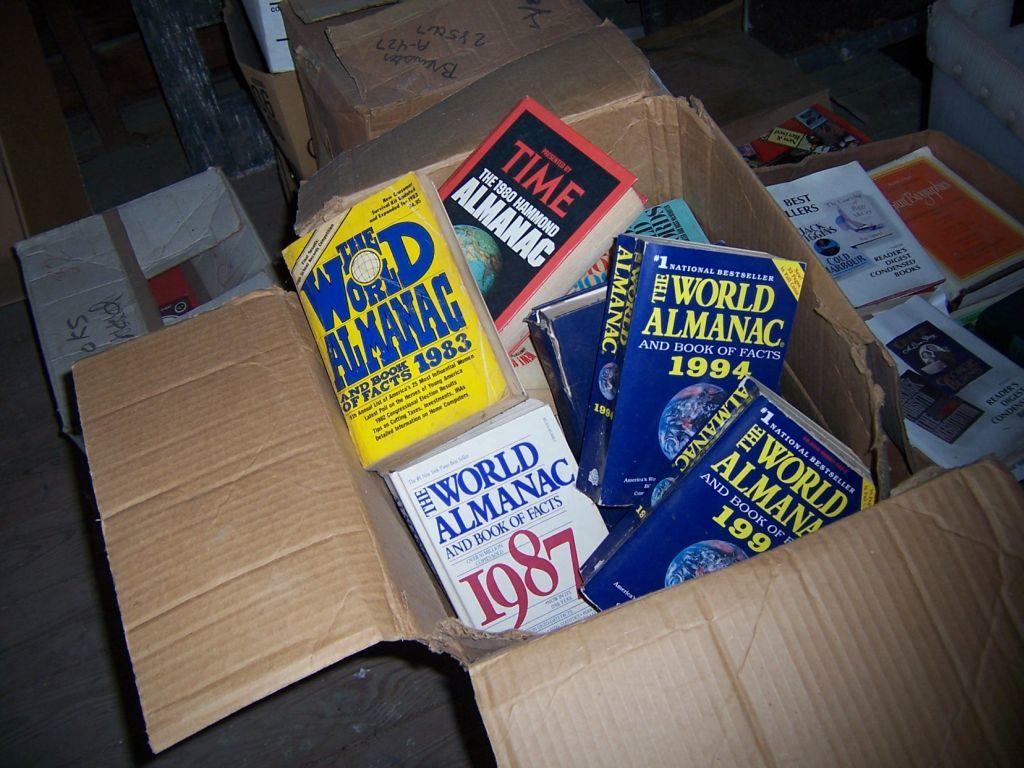What year is the world almanac from ?
Your answer should be compact. 1987. Are those almanacs?
Your answer should be very brief. Yes. 